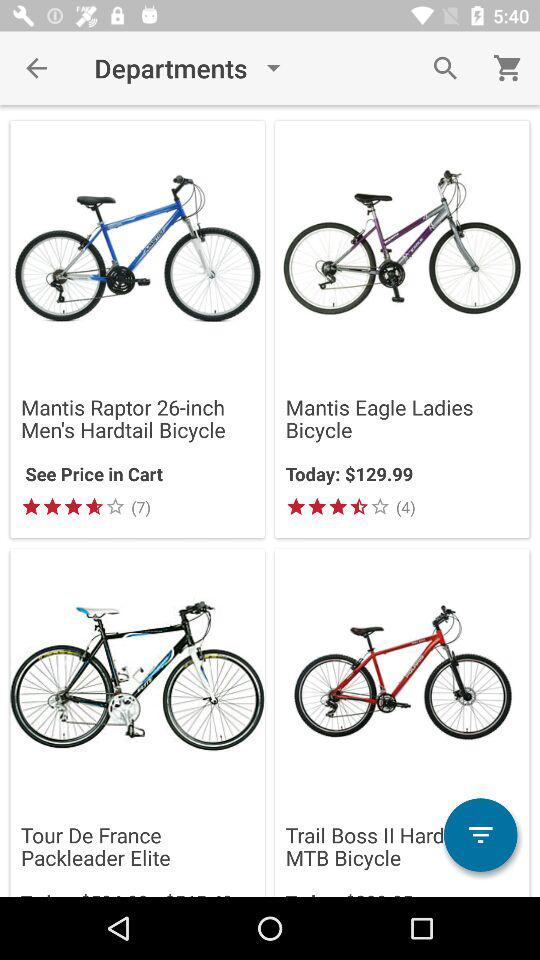What is the star rating of the "Mantis Eagle Ladies Bicycle"? The start rating is 3.5. 